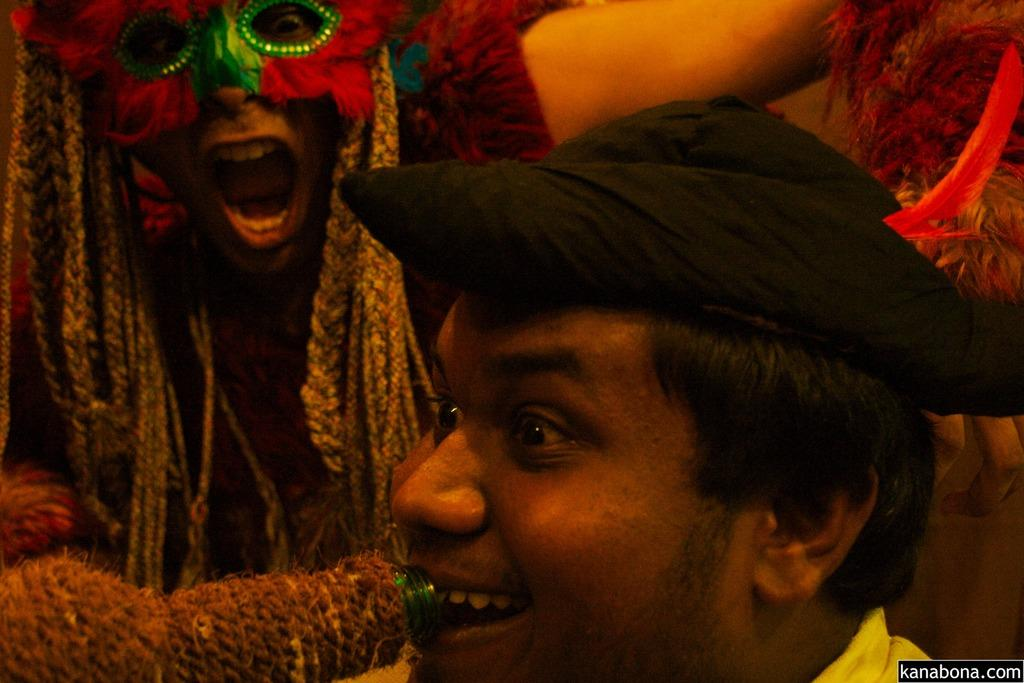How many people are in the image? There are two people in the center of the image. What are the people wearing? The people are wearing costumes. Can you describe any specific accessory in the image? Yes, there is a turban in the image. What type of watch is the person wearing in the image? There is no watch visible in the image. 